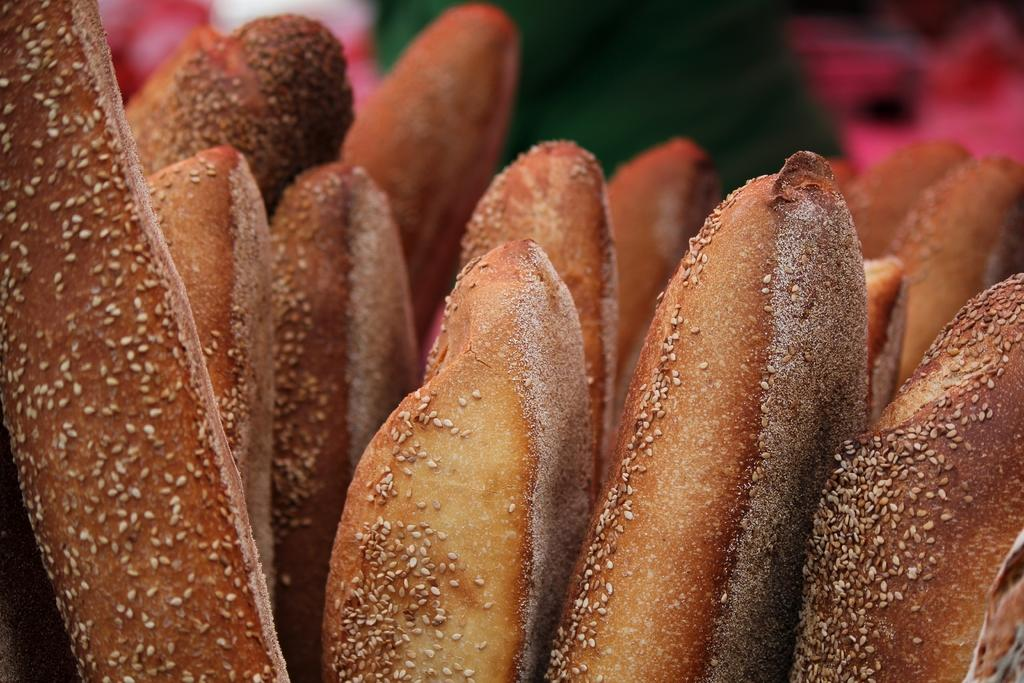What is the main subject of the image? The main subject of the image is food items. What type of rule is being enforced in the image? There is no rule being enforced in the image, as it only features food items. What riddle can be solved by examining the food items in the image? There is no riddle associated with the food items in the image. 